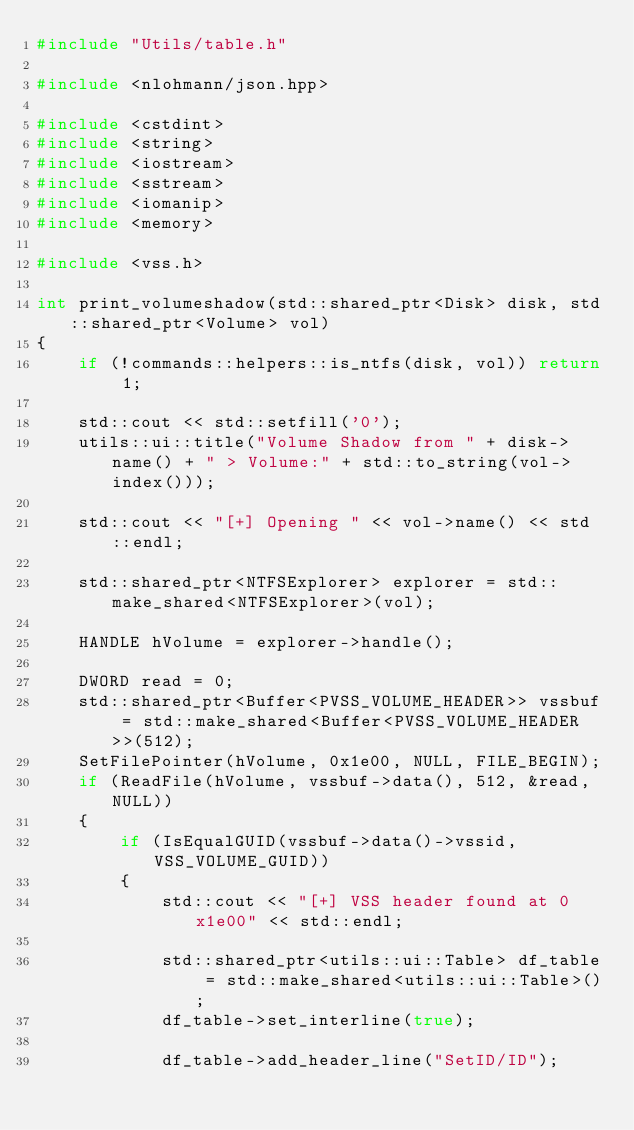<code> <loc_0><loc_0><loc_500><loc_500><_C++_>#include "Utils/table.h"

#include <nlohmann/json.hpp>

#include <cstdint>
#include <string>
#include <iostream>
#include <sstream>
#include <iomanip>
#include <memory>

#include <vss.h>

int print_volumeshadow(std::shared_ptr<Disk> disk, std::shared_ptr<Volume> vol)
{
	if (!commands::helpers::is_ntfs(disk, vol)) return 1;

	std::cout << std::setfill('0');
	utils::ui::title("Volume Shadow from " + disk->name() + " > Volume:" + std::to_string(vol->index()));

	std::cout << "[+] Opening " << vol->name() << std::endl;

	std::shared_ptr<NTFSExplorer> explorer = std::make_shared<NTFSExplorer>(vol);

	HANDLE hVolume = explorer->handle();

	DWORD read = 0;
	std::shared_ptr<Buffer<PVSS_VOLUME_HEADER>> vssbuf = std::make_shared<Buffer<PVSS_VOLUME_HEADER>>(512);
	SetFilePointer(hVolume, 0x1e00, NULL, FILE_BEGIN);
	if (ReadFile(hVolume, vssbuf->data(), 512, &read, NULL))
	{
		if (IsEqualGUID(vssbuf->data()->vssid, VSS_VOLUME_GUID))
		{
			std::cout << "[+] VSS header found at 0x1e00" << std::endl;

			std::shared_ptr<utils::ui::Table> df_table = std::make_shared<utils::ui::Table>();
			df_table->set_interline(true);

			df_table->add_header_line("SetID/ID");</code> 